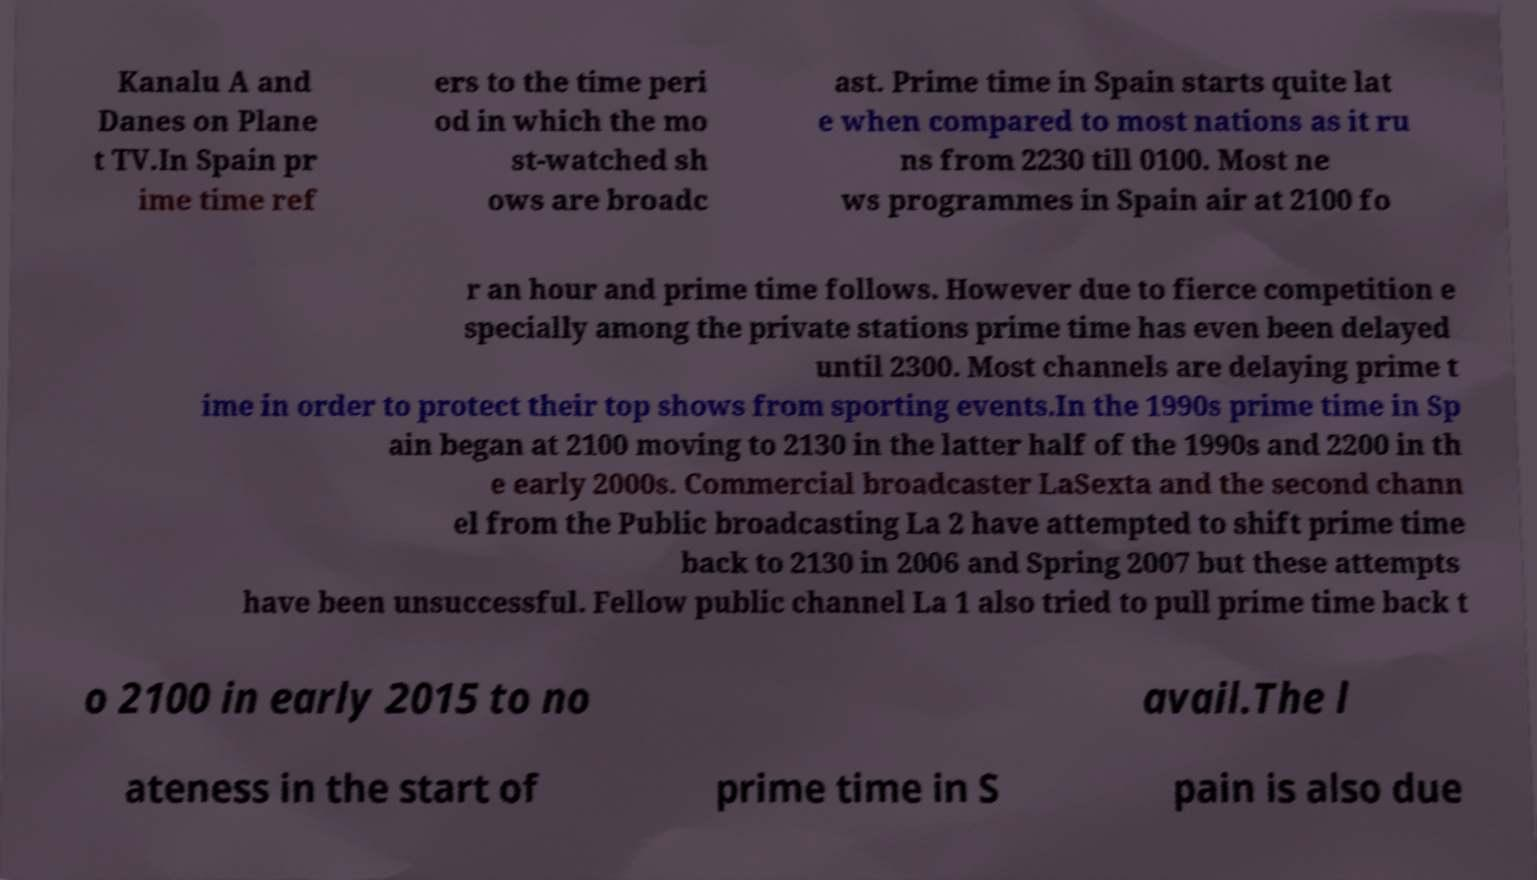Please identify and transcribe the text found in this image. Kanalu A and Danes on Plane t TV.In Spain pr ime time ref ers to the time peri od in which the mo st-watched sh ows are broadc ast. Prime time in Spain starts quite lat e when compared to most nations as it ru ns from 2230 till 0100. Most ne ws programmes in Spain air at 2100 fo r an hour and prime time follows. However due to fierce competition e specially among the private stations prime time has even been delayed until 2300. Most channels are delaying prime t ime in order to protect their top shows from sporting events.In the 1990s prime time in Sp ain began at 2100 moving to 2130 in the latter half of the 1990s and 2200 in th e early 2000s. Commercial broadcaster LaSexta and the second chann el from the Public broadcasting La 2 have attempted to shift prime time back to 2130 in 2006 and Spring 2007 but these attempts have been unsuccessful. Fellow public channel La 1 also tried to pull prime time back t o 2100 in early 2015 to no avail.The l ateness in the start of prime time in S pain is also due 